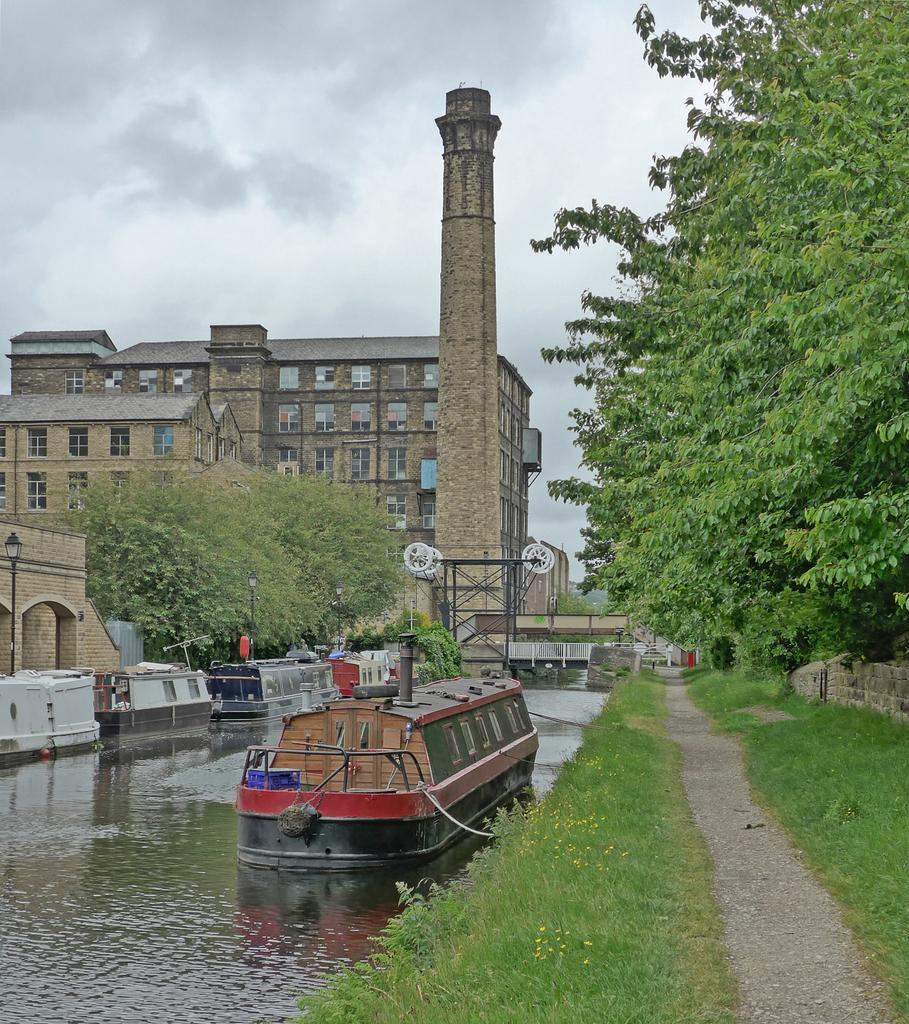What is the main subject of the image? The main subject of the image is a boat. What is the boat doing in the image? The boat is sailing on the water. What type of natural environment is visible in the image? There is grass and trees visible in the image. What type of man-made structures can be seen in the image? There are buildings visible in the image. Where are the buildings located in relation to the boat? The buildings are in the backdrop of the image. What type of book is the boat reading in the image? There is no book present in the image, and boats do not have the ability to read. 